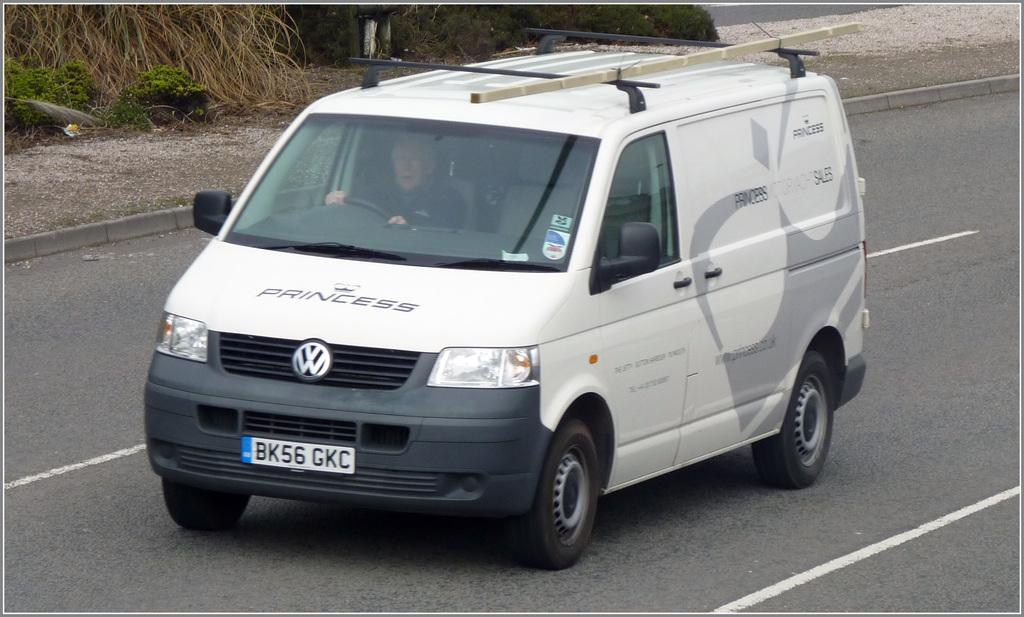<image>
Render a clear and concise summary of the photo. A white van has Princess written across the hood. 